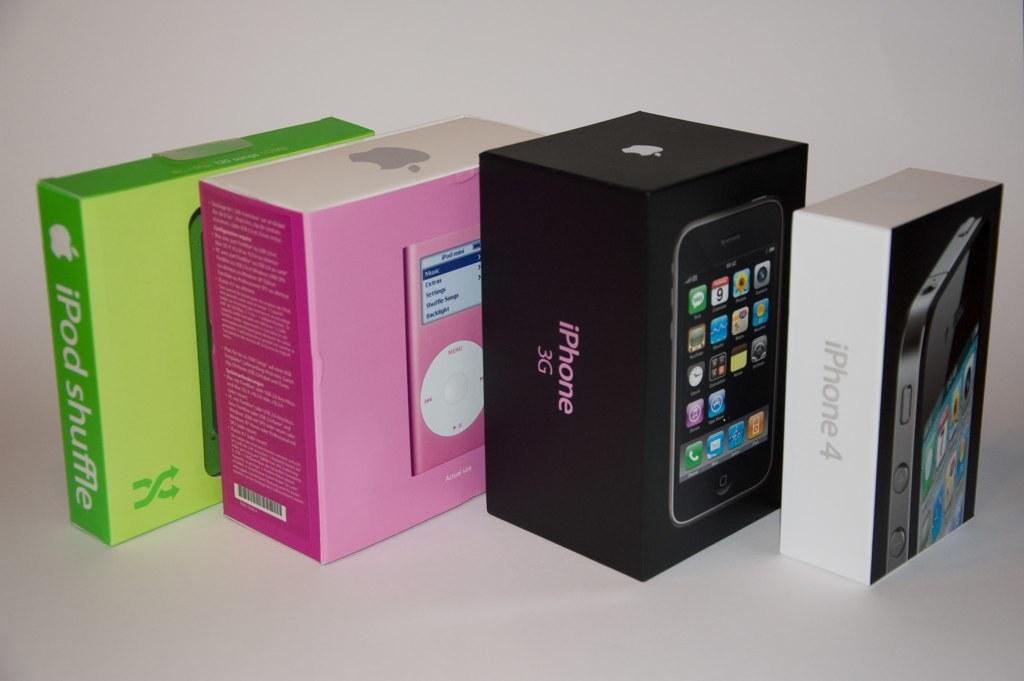What model of iphone is in the big black box?
Provide a succinct answer. 3g. What is noted as a shuffle?
Give a very brief answer. Ipod. 